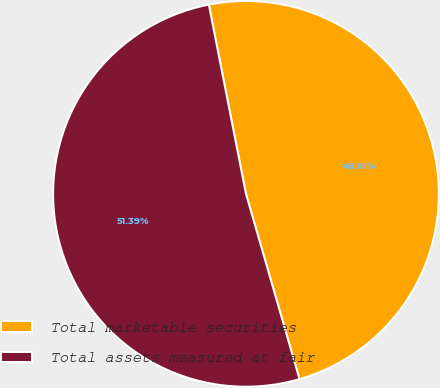Convert chart to OTSL. <chart><loc_0><loc_0><loc_500><loc_500><pie_chart><fcel>Total marketable securities<fcel>Total assets measured at fair<nl><fcel>48.61%<fcel>51.39%<nl></chart> 